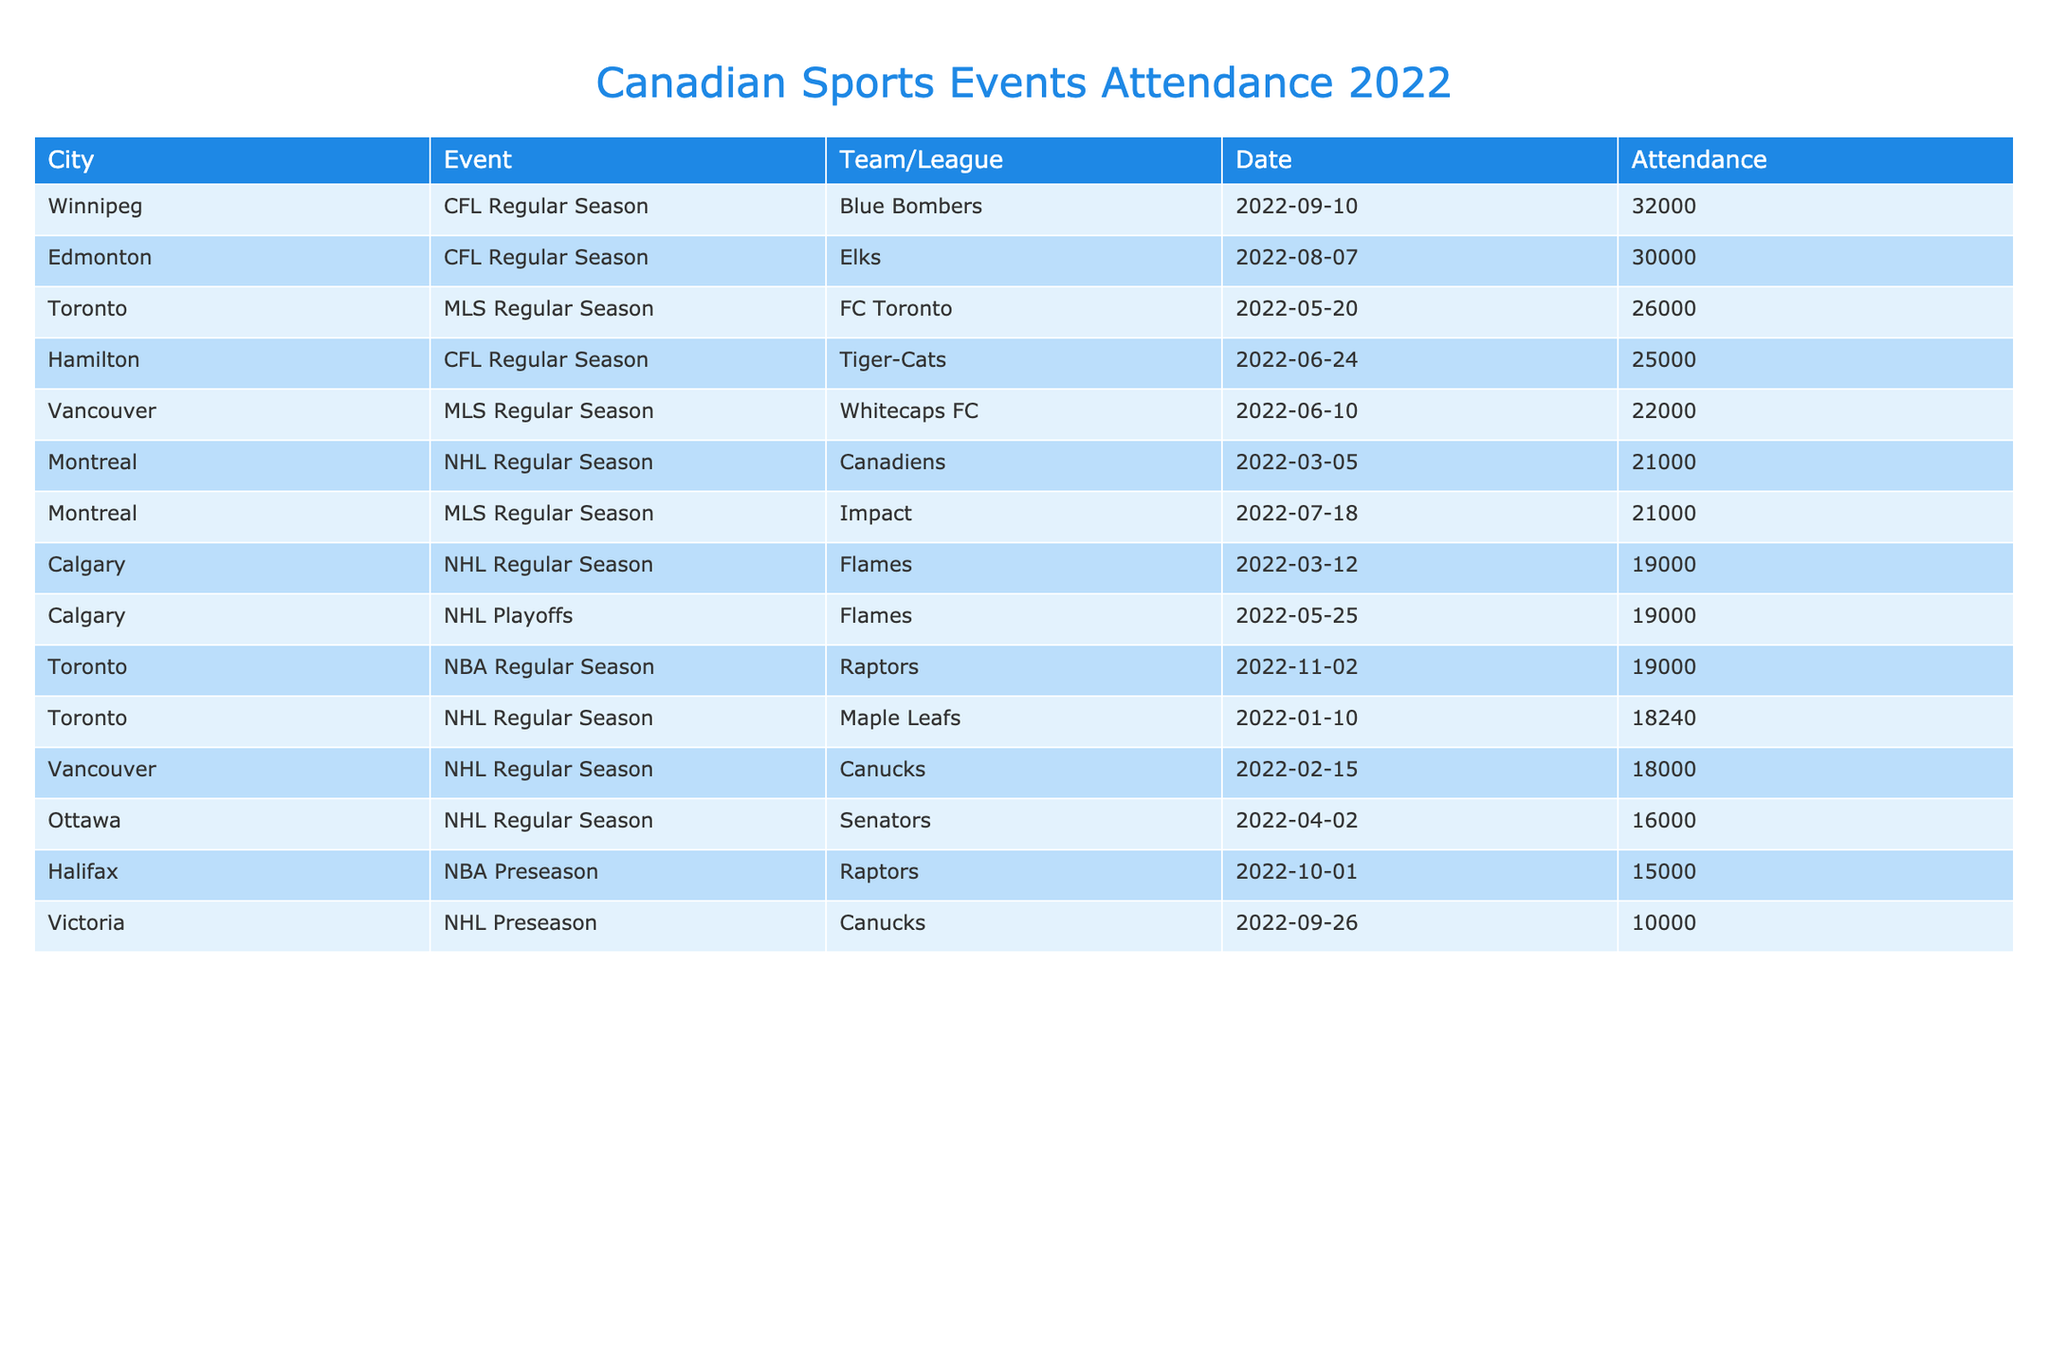What is the highest attendance figure recorded in the table? Looking at the Attendance column, the highest number is 32000 recorded for the Winnipeg Blue Bombers on September 10, 2022.
Answer: 32000 Which city had the lowest attendance for a sports event in 2022? The lowest attendance recorded is 10000 for the Victoria Canucks on September 26, 2022.
Answer: 10000 How many events had an attendance of over 20000? Reviewing the Attendance figures, the numbers over 20000 are: 21000 (Montreal Canadiens), 26000 (FC Toronto), 22000 (Vancouver Whitecaps FC), 30000 (Edmonton Elks), and 32000 (Winnipeg Blue Bombers). That's a total of 5 events.
Answer: 5 What is the total attendance for all CFL events in 2022? The attendance figures for CFL events are: 30000 (Edmonton Elks), 32000 (Winnipeg Blue Bombers), and 25000 (Hamilton Tiger-Cats). Adding these gives 30000 + 32000 + 25000 = 87000.
Answer: 87000 Did any NHL team reach an attendance of 20000 or more? The Montreal Canadiens had an attendance of 21000, which is greater than 20000. Therefore, yes, they did reach that attendance.
Answer: Yes What was the average attendance across all sports events listed? The total attendance is calculated as follows: 18240 + 18000 + 21000 + 19000 + 16000 + 26000 + 22000 + 30000 + 32000 + 15000 + 19000 + 19000 + 25000 + 10000 = 304240. With 14 events, the average is 304240 / 14 = 21731.43.
Answer: 21731.43 Which city had more events with attendance over 20000, Toronto or Vancouver? Toronto had 2 events over 20000 (FC Toronto and Maple Leafs), while Vancouver had 2 events over 20000 (Whitecaps FC and Canucks). Thus, both cities had the same number of events over 20000.
Answer: Both had the same Are there any events with an attendance of exactly 19000? Yes, there are two events with exactly 19000 attendance: the Calgary Flames on March 12, 2022, and the Toronto Raptors on November 2, 2022.
Answer: Yes 